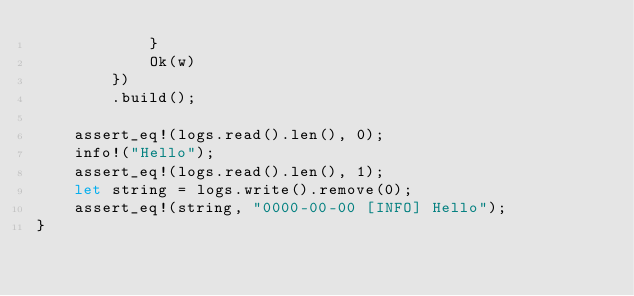Convert code to text. <code><loc_0><loc_0><loc_500><loc_500><_Rust_>            }
            Ok(w)
        })
        .build();

    assert_eq!(logs.read().len(), 0);
    info!("Hello");
    assert_eq!(logs.read().len(), 1);
    let string = logs.write().remove(0);
    assert_eq!(string, "0000-00-00 [INFO] Hello");
}
</code> 